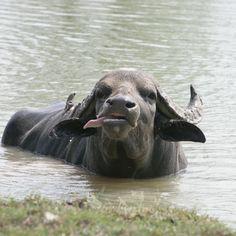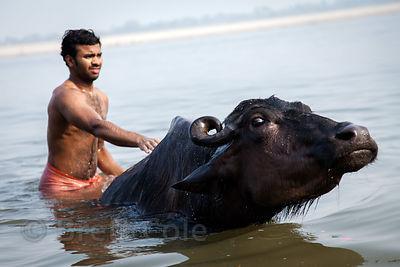The first image is the image on the left, the second image is the image on the right. Assess this claim about the two images: "The right image contains no more than one water buffalo.". Correct or not? Answer yes or no. Yes. The first image is the image on the left, the second image is the image on the right. Assess this claim about the two images: "One image shows a shirtless male standing in water and holding a hand toward a water buffalo in water to its neck.". Correct or not? Answer yes or no. Yes. 